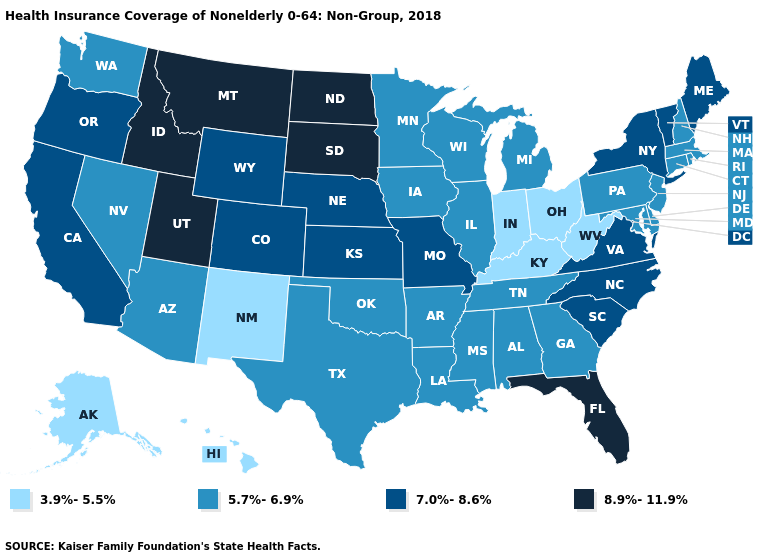What is the highest value in states that border Arizona?
Give a very brief answer. 8.9%-11.9%. Name the states that have a value in the range 7.0%-8.6%?
Write a very short answer. California, Colorado, Kansas, Maine, Missouri, Nebraska, New York, North Carolina, Oregon, South Carolina, Vermont, Virginia, Wyoming. Does New York have the lowest value in the Northeast?
Keep it brief. No. What is the highest value in states that border Missouri?
Keep it brief. 7.0%-8.6%. Among the states that border Texas , which have the lowest value?
Quick response, please. New Mexico. Name the states that have a value in the range 7.0%-8.6%?
Concise answer only. California, Colorado, Kansas, Maine, Missouri, Nebraska, New York, North Carolina, Oregon, South Carolina, Vermont, Virginia, Wyoming. Name the states that have a value in the range 7.0%-8.6%?
Give a very brief answer. California, Colorado, Kansas, Maine, Missouri, Nebraska, New York, North Carolina, Oregon, South Carolina, Vermont, Virginia, Wyoming. Among the states that border Connecticut , which have the highest value?
Be succinct. New York. Does Hawaii have the same value as Washington?
Give a very brief answer. No. What is the value of Mississippi?
Concise answer only. 5.7%-6.9%. What is the value of Wisconsin?
Keep it brief. 5.7%-6.9%. Among the states that border Tennessee , does Missouri have the highest value?
Give a very brief answer. Yes. Which states hav the highest value in the West?
Answer briefly. Idaho, Montana, Utah. What is the value of Maine?
Be succinct. 7.0%-8.6%. Is the legend a continuous bar?
Give a very brief answer. No. 